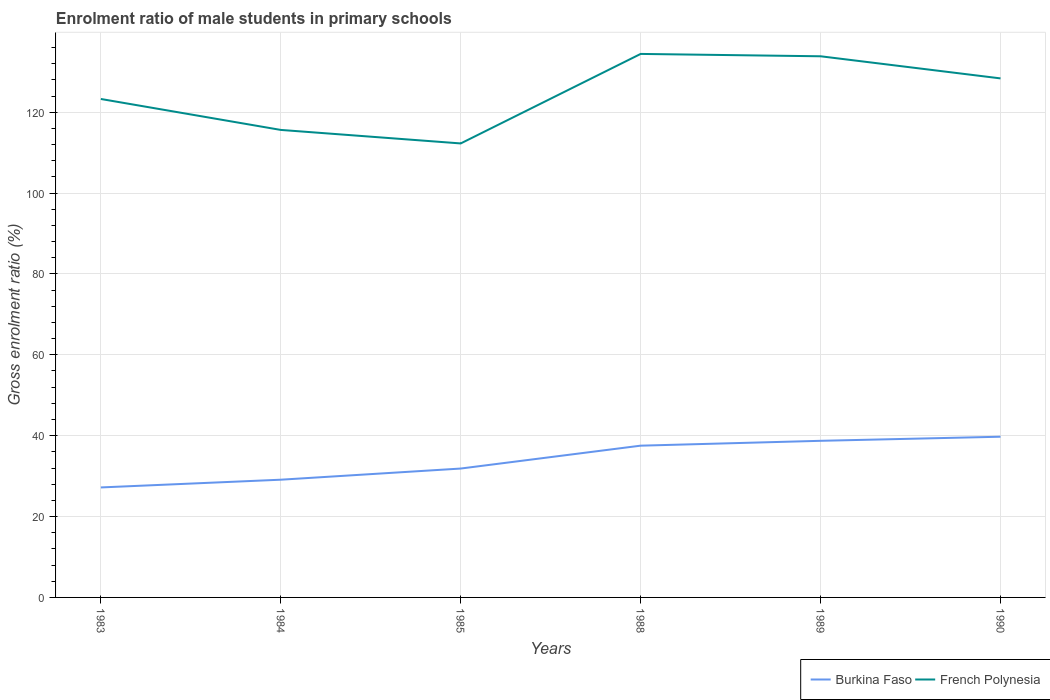Is the number of lines equal to the number of legend labels?
Provide a succinct answer. Yes. Across all years, what is the maximum enrolment ratio of male students in primary schools in French Polynesia?
Give a very brief answer. 112.28. In which year was the enrolment ratio of male students in primary schools in French Polynesia maximum?
Offer a very short reply. 1985. What is the total enrolment ratio of male students in primary schools in French Polynesia in the graph?
Your answer should be compact. 6.05. What is the difference between the highest and the second highest enrolment ratio of male students in primary schools in French Polynesia?
Your answer should be compact. 22.14. What is the difference between the highest and the lowest enrolment ratio of male students in primary schools in French Polynesia?
Offer a terse response. 3. Is the enrolment ratio of male students in primary schools in French Polynesia strictly greater than the enrolment ratio of male students in primary schools in Burkina Faso over the years?
Ensure brevity in your answer.  No. Are the values on the major ticks of Y-axis written in scientific E-notation?
Offer a very short reply. No. Does the graph contain any zero values?
Provide a succinct answer. No. Does the graph contain grids?
Offer a terse response. Yes. Where does the legend appear in the graph?
Provide a succinct answer. Bottom right. What is the title of the graph?
Offer a very short reply. Enrolment ratio of male students in primary schools. What is the label or title of the X-axis?
Make the answer very short. Years. What is the Gross enrolment ratio (%) in Burkina Faso in 1983?
Offer a terse response. 27.2. What is the Gross enrolment ratio (%) in French Polynesia in 1983?
Your answer should be very brief. 123.27. What is the Gross enrolment ratio (%) in Burkina Faso in 1984?
Your response must be concise. 29.11. What is the Gross enrolment ratio (%) in French Polynesia in 1984?
Offer a very short reply. 115.62. What is the Gross enrolment ratio (%) in Burkina Faso in 1985?
Make the answer very short. 31.87. What is the Gross enrolment ratio (%) in French Polynesia in 1985?
Your response must be concise. 112.28. What is the Gross enrolment ratio (%) in Burkina Faso in 1988?
Make the answer very short. 37.53. What is the Gross enrolment ratio (%) in French Polynesia in 1988?
Your response must be concise. 134.42. What is the Gross enrolment ratio (%) of Burkina Faso in 1989?
Provide a short and direct response. 38.73. What is the Gross enrolment ratio (%) in French Polynesia in 1989?
Provide a short and direct response. 133.83. What is the Gross enrolment ratio (%) in Burkina Faso in 1990?
Your response must be concise. 39.75. What is the Gross enrolment ratio (%) of French Polynesia in 1990?
Offer a terse response. 128.36. Across all years, what is the maximum Gross enrolment ratio (%) in Burkina Faso?
Your answer should be compact. 39.75. Across all years, what is the maximum Gross enrolment ratio (%) of French Polynesia?
Your response must be concise. 134.42. Across all years, what is the minimum Gross enrolment ratio (%) in Burkina Faso?
Offer a terse response. 27.2. Across all years, what is the minimum Gross enrolment ratio (%) of French Polynesia?
Offer a terse response. 112.28. What is the total Gross enrolment ratio (%) of Burkina Faso in the graph?
Your response must be concise. 204.2. What is the total Gross enrolment ratio (%) of French Polynesia in the graph?
Offer a terse response. 747.79. What is the difference between the Gross enrolment ratio (%) in Burkina Faso in 1983 and that in 1984?
Offer a terse response. -1.91. What is the difference between the Gross enrolment ratio (%) of French Polynesia in 1983 and that in 1984?
Ensure brevity in your answer.  7.65. What is the difference between the Gross enrolment ratio (%) in Burkina Faso in 1983 and that in 1985?
Your response must be concise. -4.67. What is the difference between the Gross enrolment ratio (%) in French Polynesia in 1983 and that in 1985?
Offer a terse response. 11. What is the difference between the Gross enrolment ratio (%) in Burkina Faso in 1983 and that in 1988?
Ensure brevity in your answer.  -10.33. What is the difference between the Gross enrolment ratio (%) of French Polynesia in 1983 and that in 1988?
Keep it short and to the point. -11.14. What is the difference between the Gross enrolment ratio (%) of Burkina Faso in 1983 and that in 1989?
Ensure brevity in your answer.  -11.53. What is the difference between the Gross enrolment ratio (%) in French Polynesia in 1983 and that in 1989?
Offer a terse response. -10.56. What is the difference between the Gross enrolment ratio (%) in Burkina Faso in 1983 and that in 1990?
Offer a very short reply. -12.54. What is the difference between the Gross enrolment ratio (%) of French Polynesia in 1983 and that in 1990?
Provide a short and direct response. -5.09. What is the difference between the Gross enrolment ratio (%) of Burkina Faso in 1984 and that in 1985?
Keep it short and to the point. -2.76. What is the difference between the Gross enrolment ratio (%) in French Polynesia in 1984 and that in 1985?
Give a very brief answer. 3.34. What is the difference between the Gross enrolment ratio (%) of Burkina Faso in 1984 and that in 1988?
Offer a very short reply. -8.42. What is the difference between the Gross enrolment ratio (%) in French Polynesia in 1984 and that in 1988?
Your response must be concise. -18.8. What is the difference between the Gross enrolment ratio (%) of Burkina Faso in 1984 and that in 1989?
Make the answer very short. -9.62. What is the difference between the Gross enrolment ratio (%) in French Polynesia in 1984 and that in 1989?
Provide a succinct answer. -18.21. What is the difference between the Gross enrolment ratio (%) in Burkina Faso in 1984 and that in 1990?
Make the answer very short. -10.63. What is the difference between the Gross enrolment ratio (%) of French Polynesia in 1984 and that in 1990?
Offer a very short reply. -12.74. What is the difference between the Gross enrolment ratio (%) in Burkina Faso in 1985 and that in 1988?
Offer a terse response. -5.66. What is the difference between the Gross enrolment ratio (%) of French Polynesia in 1985 and that in 1988?
Provide a short and direct response. -22.14. What is the difference between the Gross enrolment ratio (%) in Burkina Faso in 1985 and that in 1989?
Provide a succinct answer. -6.86. What is the difference between the Gross enrolment ratio (%) of French Polynesia in 1985 and that in 1989?
Offer a terse response. -21.56. What is the difference between the Gross enrolment ratio (%) of Burkina Faso in 1985 and that in 1990?
Give a very brief answer. -7.87. What is the difference between the Gross enrolment ratio (%) in French Polynesia in 1985 and that in 1990?
Ensure brevity in your answer.  -16.08. What is the difference between the Gross enrolment ratio (%) in Burkina Faso in 1988 and that in 1989?
Ensure brevity in your answer.  -1.2. What is the difference between the Gross enrolment ratio (%) in French Polynesia in 1988 and that in 1989?
Provide a succinct answer. 0.58. What is the difference between the Gross enrolment ratio (%) in Burkina Faso in 1988 and that in 1990?
Your response must be concise. -2.21. What is the difference between the Gross enrolment ratio (%) of French Polynesia in 1988 and that in 1990?
Give a very brief answer. 6.05. What is the difference between the Gross enrolment ratio (%) in Burkina Faso in 1989 and that in 1990?
Keep it short and to the point. -1.02. What is the difference between the Gross enrolment ratio (%) in French Polynesia in 1989 and that in 1990?
Your response must be concise. 5.47. What is the difference between the Gross enrolment ratio (%) of Burkina Faso in 1983 and the Gross enrolment ratio (%) of French Polynesia in 1984?
Give a very brief answer. -88.42. What is the difference between the Gross enrolment ratio (%) in Burkina Faso in 1983 and the Gross enrolment ratio (%) in French Polynesia in 1985?
Offer a terse response. -85.08. What is the difference between the Gross enrolment ratio (%) in Burkina Faso in 1983 and the Gross enrolment ratio (%) in French Polynesia in 1988?
Provide a succinct answer. -107.21. What is the difference between the Gross enrolment ratio (%) in Burkina Faso in 1983 and the Gross enrolment ratio (%) in French Polynesia in 1989?
Offer a terse response. -106.63. What is the difference between the Gross enrolment ratio (%) of Burkina Faso in 1983 and the Gross enrolment ratio (%) of French Polynesia in 1990?
Your answer should be compact. -101.16. What is the difference between the Gross enrolment ratio (%) in Burkina Faso in 1984 and the Gross enrolment ratio (%) in French Polynesia in 1985?
Your answer should be compact. -83.16. What is the difference between the Gross enrolment ratio (%) in Burkina Faso in 1984 and the Gross enrolment ratio (%) in French Polynesia in 1988?
Keep it short and to the point. -105.3. What is the difference between the Gross enrolment ratio (%) of Burkina Faso in 1984 and the Gross enrolment ratio (%) of French Polynesia in 1989?
Offer a terse response. -104.72. What is the difference between the Gross enrolment ratio (%) of Burkina Faso in 1984 and the Gross enrolment ratio (%) of French Polynesia in 1990?
Ensure brevity in your answer.  -99.25. What is the difference between the Gross enrolment ratio (%) of Burkina Faso in 1985 and the Gross enrolment ratio (%) of French Polynesia in 1988?
Your answer should be very brief. -102.54. What is the difference between the Gross enrolment ratio (%) in Burkina Faso in 1985 and the Gross enrolment ratio (%) in French Polynesia in 1989?
Offer a very short reply. -101.96. What is the difference between the Gross enrolment ratio (%) in Burkina Faso in 1985 and the Gross enrolment ratio (%) in French Polynesia in 1990?
Make the answer very short. -96.49. What is the difference between the Gross enrolment ratio (%) in Burkina Faso in 1988 and the Gross enrolment ratio (%) in French Polynesia in 1989?
Your answer should be very brief. -96.3. What is the difference between the Gross enrolment ratio (%) of Burkina Faso in 1988 and the Gross enrolment ratio (%) of French Polynesia in 1990?
Your response must be concise. -90.83. What is the difference between the Gross enrolment ratio (%) of Burkina Faso in 1989 and the Gross enrolment ratio (%) of French Polynesia in 1990?
Your response must be concise. -89.63. What is the average Gross enrolment ratio (%) in Burkina Faso per year?
Make the answer very short. 34.03. What is the average Gross enrolment ratio (%) in French Polynesia per year?
Offer a very short reply. 124.63. In the year 1983, what is the difference between the Gross enrolment ratio (%) of Burkina Faso and Gross enrolment ratio (%) of French Polynesia?
Your response must be concise. -96.07. In the year 1984, what is the difference between the Gross enrolment ratio (%) in Burkina Faso and Gross enrolment ratio (%) in French Polynesia?
Your response must be concise. -86.51. In the year 1985, what is the difference between the Gross enrolment ratio (%) of Burkina Faso and Gross enrolment ratio (%) of French Polynesia?
Offer a very short reply. -80.4. In the year 1988, what is the difference between the Gross enrolment ratio (%) of Burkina Faso and Gross enrolment ratio (%) of French Polynesia?
Make the answer very short. -96.88. In the year 1989, what is the difference between the Gross enrolment ratio (%) of Burkina Faso and Gross enrolment ratio (%) of French Polynesia?
Ensure brevity in your answer.  -95.1. In the year 1990, what is the difference between the Gross enrolment ratio (%) in Burkina Faso and Gross enrolment ratio (%) in French Polynesia?
Your answer should be very brief. -88.62. What is the ratio of the Gross enrolment ratio (%) of Burkina Faso in 1983 to that in 1984?
Give a very brief answer. 0.93. What is the ratio of the Gross enrolment ratio (%) in French Polynesia in 1983 to that in 1984?
Give a very brief answer. 1.07. What is the ratio of the Gross enrolment ratio (%) of Burkina Faso in 1983 to that in 1985?
Give a very brief answer. 0.85. What is the ratio of the Gross enrolment ratio (%) of French Polynesia in 1983 to that in 1985?
Your answer should be compact. 1.1. What is the ratio of the Gross enrolment ratio (%) of Burkina Faso in 1983 to that in 1988?
Your response must be concise. 0.72. What is the ratio of the Gross enrolment ratio (%) in French Polynesia in 1983 to that in 1988?
Offer a very short reply. 0.92. What is the ratio of the Gross enrolment ratio (%) in Burkina Faso in 1983 to that in 1989?
Keep it short and to the point. 0.7. What is the ratio of the Gross enrolment ratio (%) in French Polynesia in 1983 to that in 1989?
Your response must be concise. 0.92. What is the ratio of the Gross enrolment ratio (%) in Burkina Faso in 1983 to that in 1990?
Your answer should be very brief. 0.68. What is the ratio of the Gross enrolment ratio (%) of French Polynesia in 1983 to that in 1990?
Your answer should be compact. 0.96. What is the ratio of the Gross enrolment ratio (%) in Burkina Faso in 1984 to that in 1985?
Offer a terse response. 0.91. What is the ratio of the Gross enrolment ratio (%) of French Polynesia in 1984 to that in 1985?
Make the answer very short. 1.03. What is the ratio of the Gross enrolment ratio (%) in Burkina Faso in 1984 to that in 1988?
Offer a terse response. 0.78. What is the ratio of the Gross enrolment ratio (%) of French Polynesia in 1984 to that in 1988?
Keep it short and to the point. 0.86. What is the ratio of the Gross enrolment ratio (%) of Burkina Faso in 1984 to that in 1989?
Make the answer very short. 0.75. What is the ratio of the Gross enrolment ratio (%) in French Polynesia in 1984 to that in 1989?
Your answer should be very brief. 0.86. What is the ratio of the Gross enrolment ratio (%) in Burkina Faso in 1984 to that in 1990?
Provide a succinct answer. 0.73. What is the ratio of the Gross enrolment ratio (%) of French Polynesia in 1984 to that in 1990?
Give a very brief answer. 0.9. What is the ratio of the Gross enrolment ratio (%) of Burkina Faso in 1985 to that in 1988?
Keep it short and to the point. 0.85. What is the ratio of the Gross enrolment ratio (%) of French Polynesia in 1985 to that in 1988?
Your response must be concise. 0.84. What is the ratio of the Gross enrolment ratio (%) in Burkina Faso in 1985 to that in 1989?
Give a very brief answer. 0.82. What is the ratio of the Gross enrolment ratio (%) of French Polynesia in 1985 to that in 1989?
Offer a terse response. 0.84. What is the ratio of the Gross enrolment ratio (%) in Burkina Faso in 1985 to that in 1990?
Your answer should be compact. 0.8. What is the ratio of the Gross enrolment ratio (%) in French Polynesia in 1985 to that in 1990?
Your response must be concise. 0.87. What is the ratio of the Gross enrolment ratio (%) of Burkina Faso in 1988 to that in 1990?
Provide a short and direct response. 0.94. What is the ratio of the Gross enrolment ratio (%) of French Polynesia in 1988 to that in 1990?
Offer a very short reply. 1.05. What is the ratio of the Gross enrolment ratio (%) in Burkina Faso in 1989 to that in 1990?
Give a very brief answer. 0.97. What is the ratio of the Gross enrolment ratio (%) in French Polynesia in 1989 to that in 1990?
Ensure brevity in your answer.  1.04. What is the difference between the highest and the second highest Gross enrolment ratio (%) in Burkina Faso?
Your answer should be very brief. 1.02. What is the difference between the highest and the second highest Gross enrolment ratio (%) in French Polynesia?
Provide a succinct answer. 0.58. What is the difference between the highest and the lowest Gross enrolment ratio (%) of Burkina Faso?
Make the answer very short. 12.54. What is the difference between the highest and the lowest Gross enrolment ratio (%) of French Polynesia?
Provide a short and direct response. 22.14. 